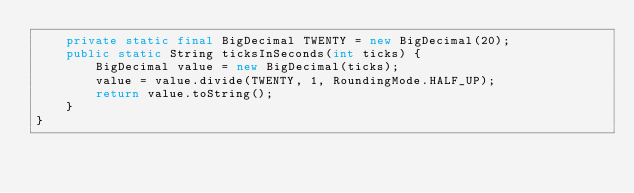<code> <loc_0><loc_0><loc_500><loc_500><_Java_>    private static final BigDecimal TWENTY = new BigDecimal(20);
    public static String ticksInSeconds(int ticks) {
        BigDecimal value = new BigDecimal(ticks);
        value = value.divide(TWENTY, 1, RoundingMode.HALF_UP);
        return value.toString();
    }
}
</code> 